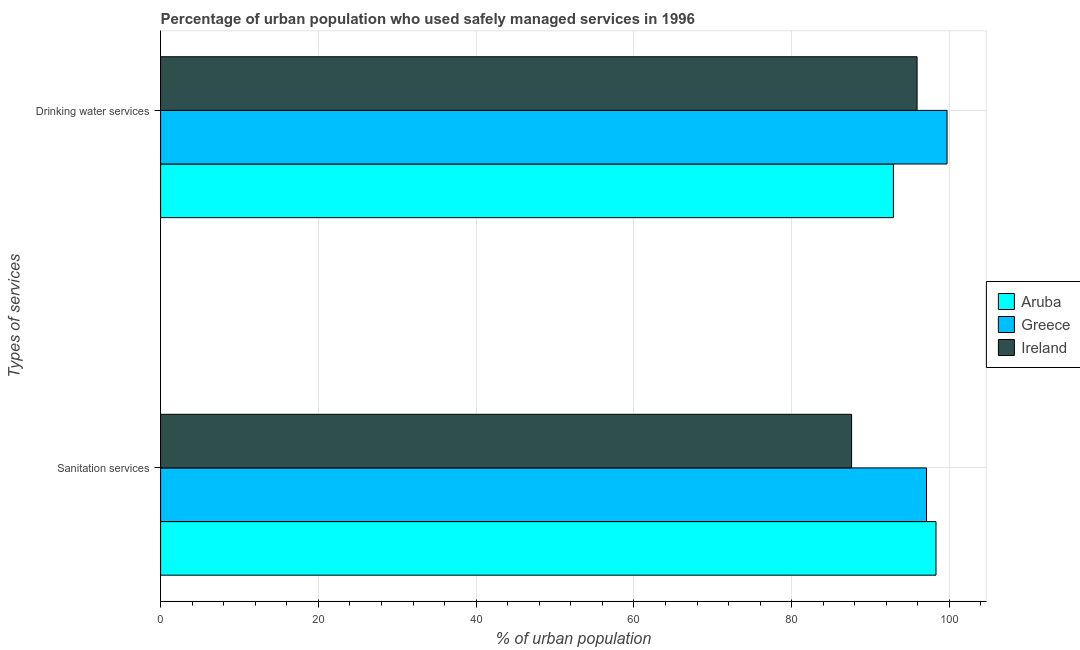How many different coloured bars are there?
Your answer should be very brief. 3. How many groups of bars are there?
Ensure brevity in your answer.  2. How many bars are there on the 2nd tick from the bottom?
Ensure brevity in your answer.  3. What is the label of the 2nd group of bars from the top?
Provide a short and direct response. Sanitation services. What is the percentage of urban population who used drinking water services in Ireland?
Provide a succinct answer. 95.9. Across all countries, what is the maximum percentage of urban population who used sanitation services?
Offer a terse response. 98.3. Across all countries, what is the minimum percentage of urban population who used sanitation services?
Provide a short and direct response. 87.6. In which country was the percentage of urban population who used drinking water services maximum?
Your answer should be very brief. Greece. In which country was the percentage of urban population who used sanitation services minimum?
Your response must be concise. Ireland. What is the total percentage of urban population who used drinking water services in the graph?
Your answer should be compact. 288.5. What is the difference between the percentage of urban population who used sanitation services in Ireland and the percentage of urban population who used drinking water services in Aruba?
Offer a very short reply. -5.3. What is the average percentage of urban population who used sanitation services per country?
Give a very brief answer. 94.33. What is the difference between the percentage of urban population who used sanitation services and percentage of urban population who used drinking water services in Ireland?
Your answer should be very brief. -8.3. In how many countries, is the percentage of urban population who used sanitation services greater than 16 %?
Provide a short and direct response. 3. What is the ratio of the percentage of urban population who used sanitation services in Ireland to that in Greece?
Give a very brief answer. 0.9. In how many countries, is the percentage of urban population who used sanitation services greater than the average percentage of urban population who used sanitation services taken over all countries?
Offer a very short reply. 2. What does the 2nd bar from the bottom in Sanitation services represents?
Offer a terse response. Greece. How many bars are there?
Your answer should be very brief. 6. Are all the bars in the graph horizontal?
Your answer should be very brief. Yes. How many countries are there in the graph?
Provide a short and direct response. 3. Are the values on the major ticks of X-axis written in scientific E-notation?
Provide a succinct answer. No. Where does the legend appear in the graph?
Keep it short and to the point. Center right. How many legend labels are there?
Offer a terse response. 3. How are the legend labels stacked?
Keep it short and to the point. Vertical. What is the title of the graph?
Make the answer very short. Percentage of urban population who used safely managed services in 1996. Does "Comoros" appear as one of the legend labels in the graph?
Make the answer very short. No. What is the label or title of the X-axis?
Keep it short and to the point. % of urban population. What is the label or title of the Y-axis?
Make the answer very short. Types of services. What is the % of urban population of Aruba in Sanitation services?
Give a very brief answer. 98.3. What is the % of urban population in Greece in Sanitation services?
Ensure brevity in your answer.  97.1. What is the % of urban population of Ireland in Sanitation services?
Provide a short and direct response. 87.6. What is the % of urban population in Aruba in Drinking water services?
Provide a short and direct response. 92.9. What is the % of urban population in Greece in Drinking water services?
Provide a succinct answer. 99.7. What is the % of urban population in Ireland in Drinking water services?
Offer a very short reply. 95.9. Across all Types of services, what is the maximum % of urban population of Aruba?
Offer a very short reply. 98.3. Across all Types of services, what is the maximum % of urban population of Greece?
Your answer should be very brief. 99.7. Across all Types of services, what is the maximum % of urban population of Ireland?
Make the answer very short. 95.9. Across all Types of services, what is the minimum % of urban population of Aruba?
Give a very brief answer. 92.9. Across all Types of services, what is the minimum % of urban population of Greece?
Your answer should be very brief. 97.1. Across all Types of services, what is the minimum % of urban population of Ireland?
Give a very brief answer. 87.6. What is the total % of urban population of Aruba in the graph?
Provide a short and direct response. 191.2. What is the total % of urban population of Greece in the graph?
Keep it short and to the point. 196.8. What is the total % of urban population of Ireland in the graph?
Keep it short and to the point. 183.5. What is the difference between the % of urban population of Greece in Sanitation services and that in Drinking water services?
Provide a succinct answer. -2.6. What is the difference between the % of urban population in Ireland in Sanitation services and that in Drinking water services?
Your answer should be very brief. -8.3. What is the difference between the % of urban population in Aruba in Sanitation services and the % of urban population in Greece in Drinking water services?
Keep it short and to the point. -1.4. What is the difference between the % of urban population of Aruba in Sanitation services and the % of urban population of Ireland in Drinking water services?
Make the answer very short. 2.4. What is the average % of urban population of Aruba per Types of services?
Give a very brief answer. 95.6. What is the average % of urban population in Greece per Types of services?
Provide a succinct answer. 98.4. What is the average % of urban population of Ireland per Types of services?
Provide a short and direct response. 91.75. What is the difference between the % of urban population of Aruba and % of urban population of Greece in Sanitation services?
Provide a succinct answer. 1.2. What is the difference between the % of urban population in Aruba and % of urban population in Ireland in Sanitation services?
Your response must be concise. 10.7. What is the difference between the % of urban population of Greece and % of urban population of Ireland in Sanitation services?
Your answer should be very brief. 9.5. What is the difference between the % of urban population of Aruba and % of urban population of Greece in Drinking water services?
Your response must be concise. -6.8. What is the difference between the % of urban population in Greece and % of urban population in Ireland in Drinking water services?
Make the answer very short. 3.8. What is the ratio of the % of urban population in Aruba in Sanitation services to that in Drinking water services?
Keep it short and to the point. 1.06. What is the ratio of the % of urban population of Greece in Sanitation services to that in Drinking water services?
Give a very brief answer. 0.97. What is the ratio of the % of urban population of Ireland in Sanitation services to that in Drinking water services?
Your response must be concise. 0.91. What is the difference between the highest and the second highest % of urban population in Aruba?
Offer a very short reply. 5.4. What is the difference between the highest and the lowest % of urban population of Aruba?
Offer a very short reply. 5.4. What is the difference between the highest and the lowest % of urban population of Ireland?
Offer a very short reply. 8.3. 